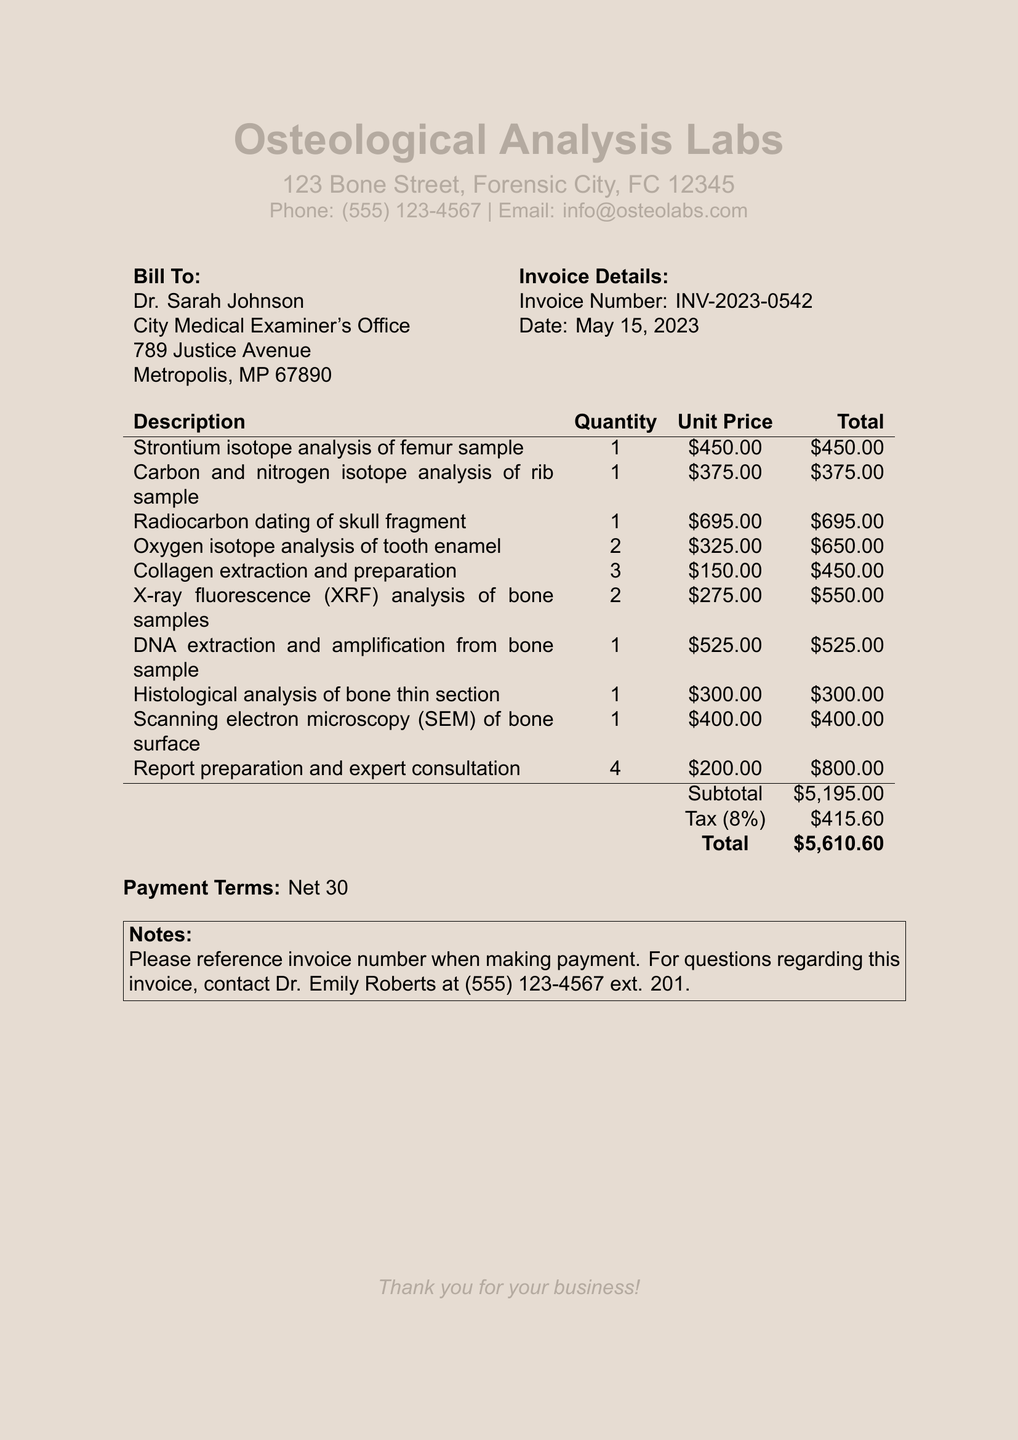What is the invoice number? The invoice number is stated in the document under "Invoice Details".
Answer: INV-2023-0542 Who is the client? The client's name is provided in the "Bill To" section of the document.
Answer: Dr. Sarah Johnson What is the date of the invoice? The date of the invoice is mentioned in the "Invoice Details" section.
Answer: May 15, 2023 What is the total amount due? The total amount is calculated at the end of the invoice, after subtotal and tax.
Answer: $5,610.60 How many services were provided? The number of services can be counted from the "Description" column in the services section.
Answer: 10 What is the tax rate applied to the invoice? The tax rate is specified in the invoice, to calculate the tax amount.
Answer: 8% What service has the highest unit price? The service with the highest unit price is identified in the services list by comparing each unit price.
Answer: Radiocarbon dating of skull fragment What is the subtotal amount before tax? The subtotal is listed before the tax amount and totals all services provided.
Answer: $5,195.00 What are the payment terms for this invoice? The payment terms are explicitly stated in the last part of the invoice.
Answer: Net 30 Who should be contacted for questions regarding this invoice? The contact for inquiries is listed in the notes section of the invoice.
Answer: Dr. Emily Roberts 